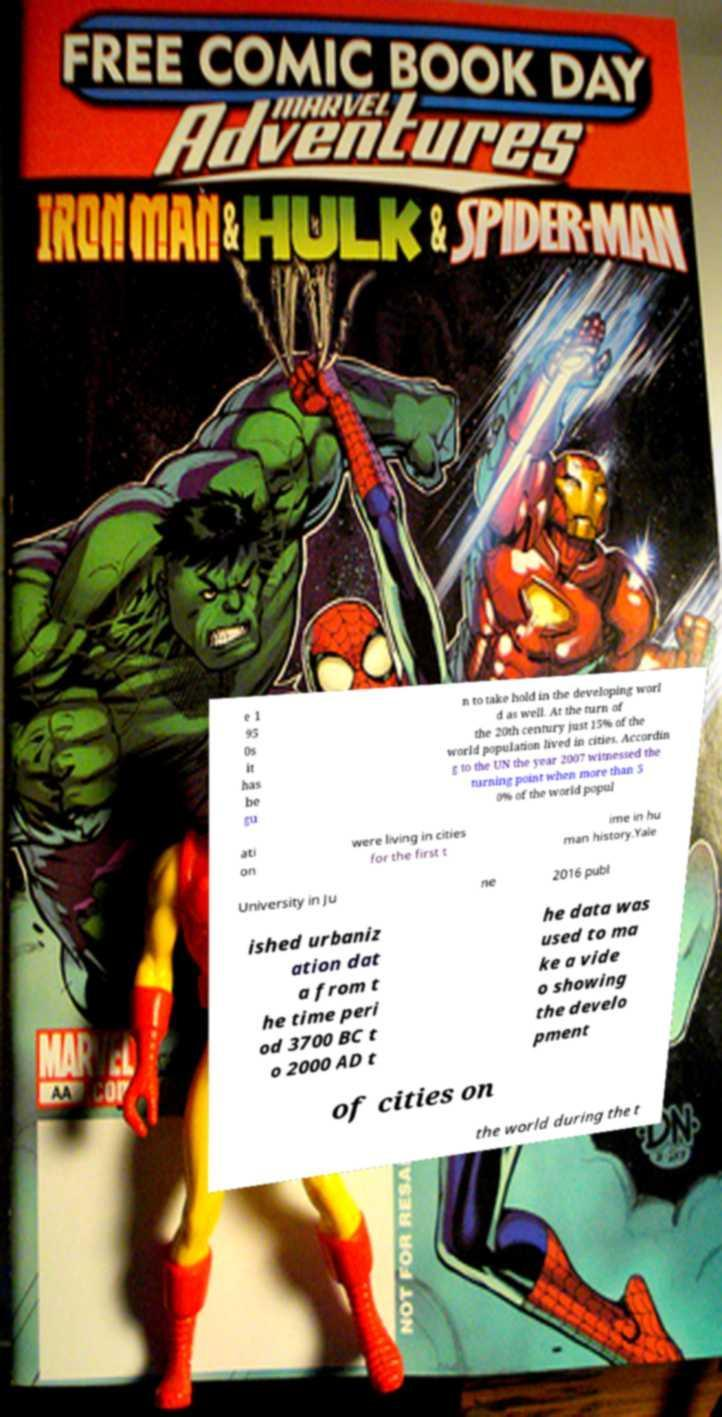Please read and relay the text visible in this image. What does it say? e 1 95 0s it has be gu n to take hold in the developing worl d as well. At the turn of the 20th century just 15% of the world population lived in cities. Accordin g to the UN the year 2007 witnessed the turning point when more than 5 0% of the world popul ati on were living in cities for the first t ime in hu man history.Yale University in Ju ne 2016 publ ished urbaniz ation dat a from t he time peri od 3700 BC t o 2000 AD t he data was used to ma ke a vide o showing the develo pment of cities on the world during the t 